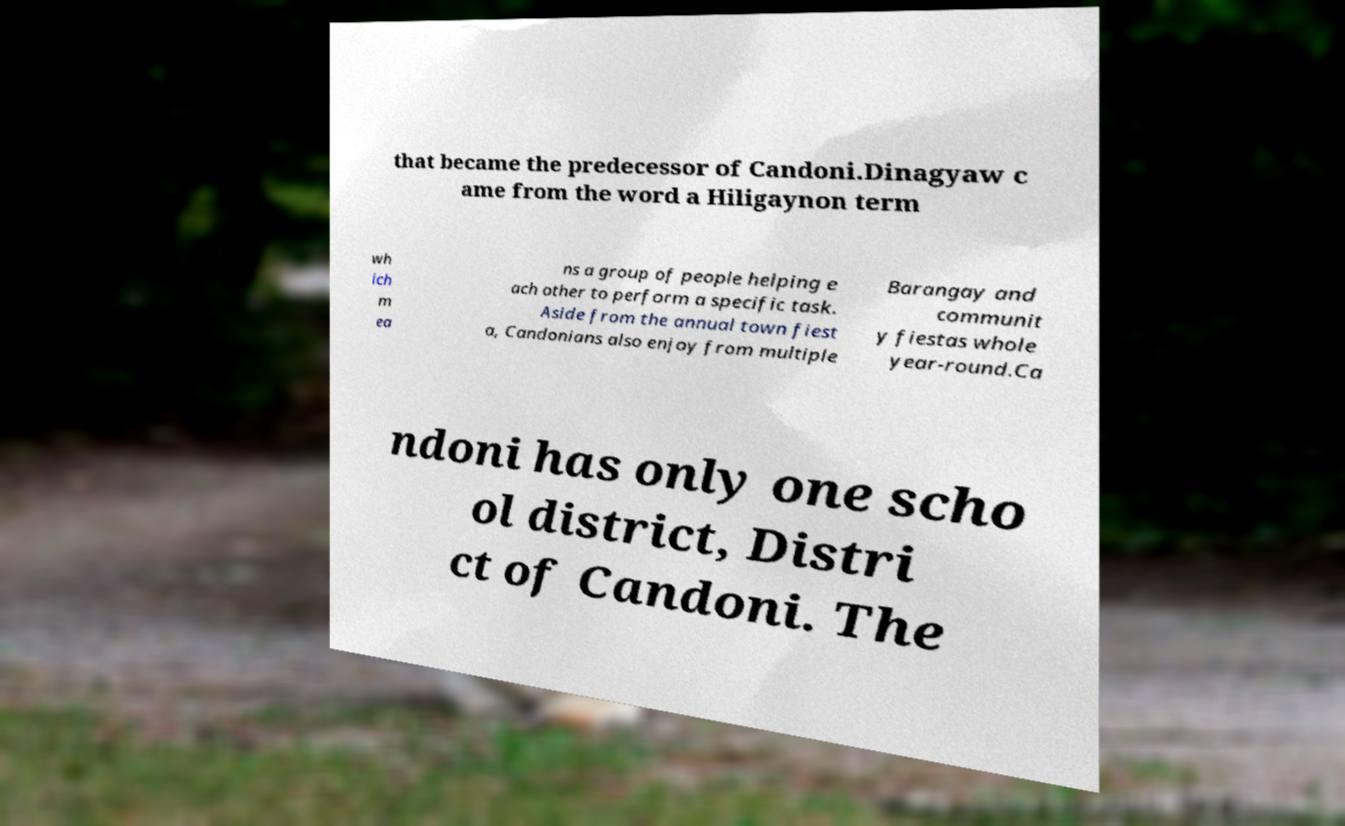Could you extract and type out the text from this image? that became the predecessor of Candoni.Dinagyaw c ame from the word a Hiligaynon term wh ich m ea ns a group of people helping e ach other to perform a specific task. Aside from the annual town fiest a, Candonians also enjoy from multiple Barangay and communit y fiestas whole year-round.Ca ndoni has only one scho ol district, Distri ct of Candoni. The 